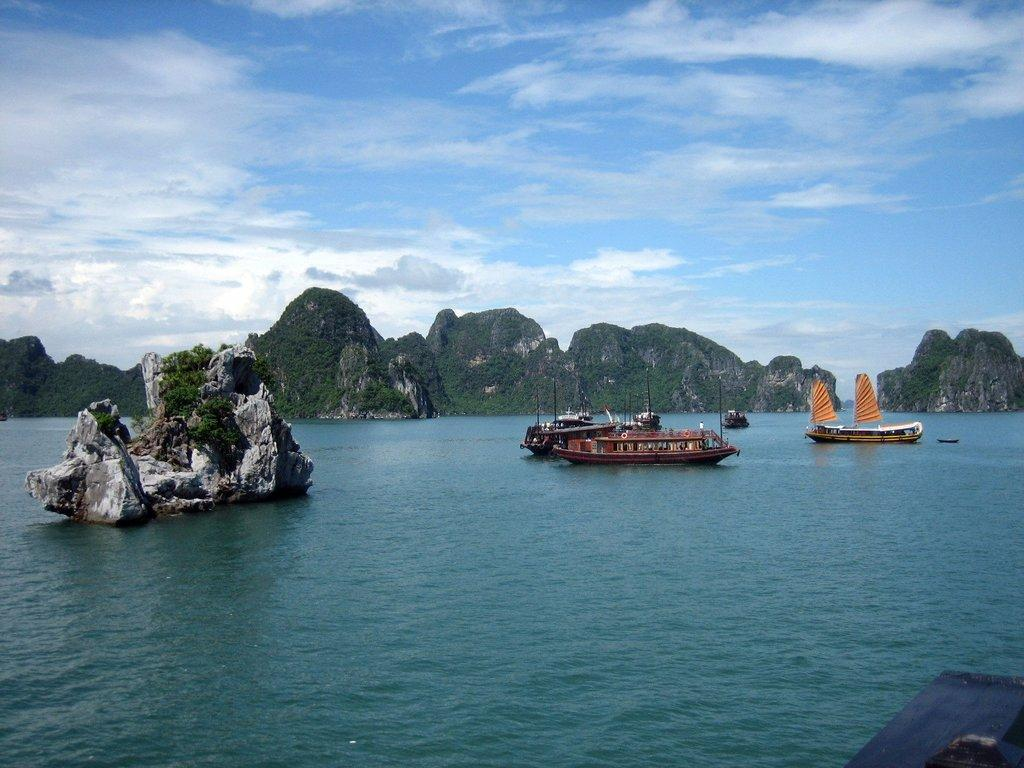What is in the water in the image? There are boats, plants, and rocks in the water. What can be seen in the background of the image? Mountains and trees are visible in the background. What is the color and condition of the sky in the image? The sky is blue and cloudy. How does the sneeze affect the boats in the image? There is no sneeze present in the image, so it cannot affect the boats. What type of elbow is visible in the image? There is no elbow present in the image. 